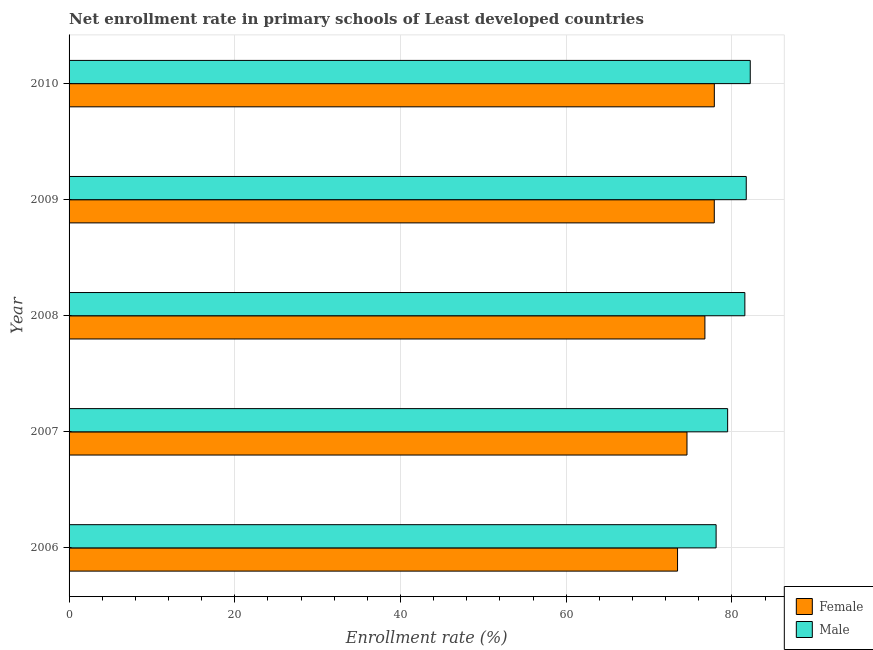How many different coloured bars are there?
Your answer should be very brief. 2. How many bars are there on the 2nd tick from the top?
Provide a succinct answer. 2. In how many cases, is the number of bars for a given year not equal to the number of legend labels?
Offer a terse response. 0. What is the enrollment rate of female students in 2007?
Provide a short and direct response. 74.57. Across all years, what is the maximum enrollment rate of female students?
Provide a succinct answer. 77.87. Across all years, what is the minimum enrollment rate of female students?
Your answer should be very brief. 73.43. What is the total enrollment rate of female students in the graph?
Provide a succinct answer. 380.47. What is the difference between the enrollment rate of female students in 2007 and that in 2009?
Offer a very short reply. -3.29. What is the difference between the enrollment rate of female students in 2010 and the enrollment rate of male students in 2008?
Your answer should be compact. -3.68. What is the average enrollment rate of female students per year?
Provide a succinct answer. 76.09. In the year 2007, what is the difference between the enrollment rate of male students and enrollment rate of female students?
Your response must be concise. 4.91. What is the difference between the highest and the second highest enrollment rate of male students?
Your answer should be very brief. 0.48. What is the difference between the highest and the lowest enrollment rate of female students?
Make the answer very short. 4.44. Is the sum of the enrollment rate of male students in 2007 and 2008 greater than the maximum enrollment rate of female students across all years?
Keep it short and to the point. Yes. How many bars are there?
Your answer should be compact. 10. Are all the bars in the graph horizontal?
Your answer should be very brief. Yes. How many years are there in the graph?
Offer a terse response. 5. What is the difference between two consecutive major ticks on the X-axis?
Provide a short and direct response. 20. Does the graph contain any zero values?
Ensure brevity in your answer.  No. Does the graph contain grids?
Ensure brevity in your answer.  Yes. Where does the legend appear in the graph?
Provide a succinct answer. Bottom right. How many legend labels are there?
Offer a terse response. 2. How are the legend labels stacked?
Offer a terse response. Vertical. What is the title of the graph?
Your answer should be very brief. Net enrollment rate in primary schools of Least developed countries. What is the label or title of the X-axis?
Provide a succinct answer. Enrollment rate (%). What is the label or title of the Y-axis?
Provide a succinct answer. Year. What is the Enrollment rate (%) in Female in 2006?
Offer a very short reply. 73.43. What is the Enrollment rate (%) in Male in 2006?
Provide a short and direct response. 78.08. What is the Enrollment rate (%) in Female in 2007?
Ensure brevity in your answer.  74.57. What is the Enrollment rate (%) in Male in 2007?
Provide a short and direct response. 79.48. What is the Enrollment rate (%) of Female in 2008?
Make the answer very short. 76.73. What is the Enrollment rate (%) of Male in 2008?
Your response must be concise. 81.55. What is the Enrollment rate (%) of Female in 2009?
Offer a terse response. 77.86. What is the Enrollment rate (%) in Male in 2009?
Provide a short and direct response. 81.72. What is the Enrollment rate (%) in Female in 2010?
Give a very brief answer. 77.87. What is the Enrollment rate (%) of Male in 2010?
Your answer should be compact. 82.2. Across all years, what is the maximum Enrollment rate (%) of Female?
Offer a terse response. 77.87. Across all years, what is the maximum Enrollment rate (%) of Male?
Give a very brief answer. 82.2. Across all years, what is the minimum Enrollment rate (%) of Female?
Keep it short and to the point. 73.43. Across all years, what is the minimum Enrollment rate (%) in Male?
Offer a terse response. 78.08. What is the total Enrollment rate (%) in Female in the graph?
Provide a short and direct response. 380.47. What is the total Enrollment rate (%) in Male in the graph?
Give a very brief answer. 403.04. What is the difference between the Enrollment rate (%) of Female in 2006 and that in 2007?
Ensure brevity in your answer.  -1.14. What is the difference between the Enrollment rate (%) of Male in 2006 and that in 2007?
Give a very brief answer. -1.39. What is the difference between the Enrollment rate (%) of Female in 2006 and that in 2008?
Offer a terse response. -3.3. What is the difference between the Enrollment rate (%) in Male in 2006 and that in 2008?
Offer a very short reply. -3.47. What is the difference between the Enrollment rate (%) of Female in 2006 and that in 2009?
Provide a succinct answer. -4.43. What is the difference between the Enrollment rate (%) of Male in 2006 and that in 2009?
Give a very brief answer. -3.64. What is the difference between the Enrollment rate (%) in Female in 2006 and that in 2010?
Your answer should be compact. -4.44. What is the difference between the Enrollment rate (%) in Male in 2006 and that in 2010?
Offer a terse response. -4.12. What is the difference between the Enrollment rate (%) of Female in 2007 and that in 2008?
Your answer should be compact. -2.16. What is the difference between the Enrollment rate (%) of Male in 2007 and that in 2008?
Make the answer very short. -2.08. What is the difference between the Enrollment rate (%) of Female in 2007 and that in 2009?
Offer a very short reply. -3.29. What is the difference between the Enrollment rate (%) of Male in 2007 and that in 2009?
Your answer should be very brief. -2.25. What is the difference between the Enrollment rate (%) of Female in 2007 and that in 2010?
Keep it short and to the point. -3.3. What is the difference between the Enrollment rate (%) in Male in 2007 and that in 2010?
Give a very brief answer. -2.73. What is the difference between the Enrollment rate (%) in Female in 2008 and that in 2009?
Offer a terse response. -1.13. What is the difference between the Enrollment rate (%) of Male in 2008 and that in 2009?
Provide a short and direct response. -0.17. What is the difference between the Enrollment rate (%) in Female in 2008 and that in 2010?
Provide a short and direct response. -1.14. What is the difference between the Enrollment rate (%) of Male in 2008 and that in 2010?
Ensure brevity in your answer.  -0.65. What is the difference between the Enrollment rate (%) of Female in 2009 and that in 2010?
Provide a short and direct response. -0.01. What is the difference between the Enrollment rate (%) of Male in 2009 and that in 2010?
Provide a short and direct response. -0.48. What is the difference between the Enrollment rate (%) of Female in 2006 and the Enrollment rate (%) of Male in 2007?
Your response must be concise. -6.04. What is the difference between the Enrollment rate (%) of Female in 2006 and the Enrollment rate (%) of Male in 2008?
Make the answer very short. -8.12. What is the difference between the Enrollment rate (%) of Female in 2006 and the Enrollment rate (%) of Male in 2009?
Your answer should be compact. -8.29. What is the difference between the Enrollment rate (%) in Female in 2006 and the Enrollment rate (%) in Male in 2010?
Offer a very short reply. -8.77. What is the difference between the Enrollment rate (%) in Female in 2007 and the Enrollment rate (%) in Male in 2008?
Offer a terse response. -6.98. What is the difference between the Enrollment rate (%) of Female in 2007 and the Enrollment rate (%) of Male in 2009?
Make the answer very short. -7.15. What is the difference between the Enrollment rate (%) in Female in 2007 and the Enrollment rate (%) in Male in 2010?
Make the answer very short. -7.63. What is the difference between the Enrollment rate (%) of Female in 2008 and the Enrollment rate (%) of Male in 2009?
Your answer should be compact. -4.99. What is the difference between the Enrollment rate (%) of Female in 2008 and the Enrollment rate (%) of Male in 2010?
Your answer should be compact. -5.47. What is the difference between the Enrollment rate (%) in Female in 2009 and the Enrollment rate (%) in Male in 2010?
Ensure brevity in your answer.  -4.34. What is the average Enrollment rate (%) of Female per year?
Your response must be concise. 76.09. What is the average Enrollment rate (%) of Male per year?
Ensure brevity in your answer.  80.61. In the year 2006, what is the difference between the Enrollment rate (%) of Female and Enrollment rate (%) of Male?
Your answer should be compact. -4.65. In the year 2007, what is the difference between the Enrollment rate (%) in Female and Enrollment rate (%) in Male?
Make the answer very short. -4.91. In the year 2008, what is the difference between the Enrollment rate (%) of Female and Enrollment rate (%) of Male?
Your answer should be compact. -4.82. In the year 2009, what is the difference between the Enrollment rate (%) of Female and Enrollment rate (%) of Male?
Provide a succinct answer. -3.86. In the year 2010, what is the difference between the Enrollment rate (%) of Female and Enrollment rate (%) of Male?
Your answer should be very brief. -4.33. What is the ratio of the Enrollment rate (%) in Female in 2006 to that in 2007?
Give a very brief answer. 0.98. What is the ratio of the Enrollment rate (%) in Male in 2006 to that in 2007?
Ensure brevity in your answer.  0.98. What is the ratio of the Enrollment rate (%) in Male in 2006 to that in 2008?
Make the answer very short. 0.96. What is the ratio of the Enrollment rate (%) in Female in 2006 to that in 2009?
Offer a very short reply. 0.94. What is the ratio of the Enrollment rate (%) in Male in 2006 to that in 2009?
Keep it short and to the point. 0.96. What is the ratio of the Enrollment rate (%) in Female in 2006 to that in 2010?
Your answer should be compact. 0.94. What is the ratio of the Enrollment rate (%) of Male in 2006 to that in 2010?
Ensure brevity in your answer.  0.95. What is the ratio of the Enrollment rate (%) of Female in 2007 to that in 2008?
Offer a terse response. 0.97. What is the ratio of the Enrollment rate (%) in Male in 2007 to that in 2008?
Provide a short and direct response. 0.97. What is the ratio of the Enrollment rate (%) in Female in 2007 to that in 2009?
Provide a succinct answer. 0.96. What is the ratio of the Enrollment rate (%) in Male in 2007 to that in 2009?
Your answer should be very brief. 0.97. What is the ratio of the Enrollment rate (%) of Female in 2007 to that in 2010?
Give a very brief answer. 0.96. What is the ratio of the Enrollment rate (%) in Male in 2007 to that in 2010?
Ensure brevity in your answer.  0.97. What is the ratio of the Enrollment rate (%) in Female in 2008 to that in 2009?
Provide a short and direct response. 0.99. What is the ratio of the Enrollment rate (%) of Male in 2008 to that in 2009?
Offer a very short reply. 1. What is the ratio of the Enrollment rate (%) of Female in 2008 to that in 2010?
Provide a succinct answer. 0.99. What is the difference between the highest and the second highest Enrollment rate (%) of Female?
Your answer should be very brief. 0.01. What is the difference between the highest and the second highest Enrollment rate (%) in Male?
Make the answer very short. 0.48. What is the difference between the highest and the lowest Enrollment rate (%) in Female?
Offer a terse response. 4.44. What is the difference between the highest and the lowest Enrollment rate (%) in Male?
Give a very brief answer. 4.12. 